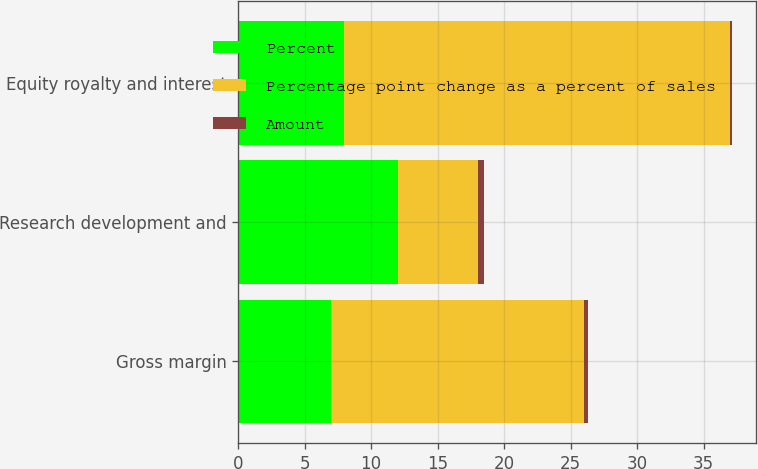Convert chart. <chart><loc_0><loc_0><loc_500><loc_500><stacked_bar_chart><ecel><fcel>Gross margin<fcel>Research development and<fcel>Equity royalty and interest<nl><fcel>Percent<fcel>7<fcel>12<fcel>8<nl><fcel>Percentage point change as a percent of sales<fcel>19<fcel>6<fcel>29<nl><fcel>Amount<fcel>0.3<fcel>0.5<fcel>0.1<nl></chart> 